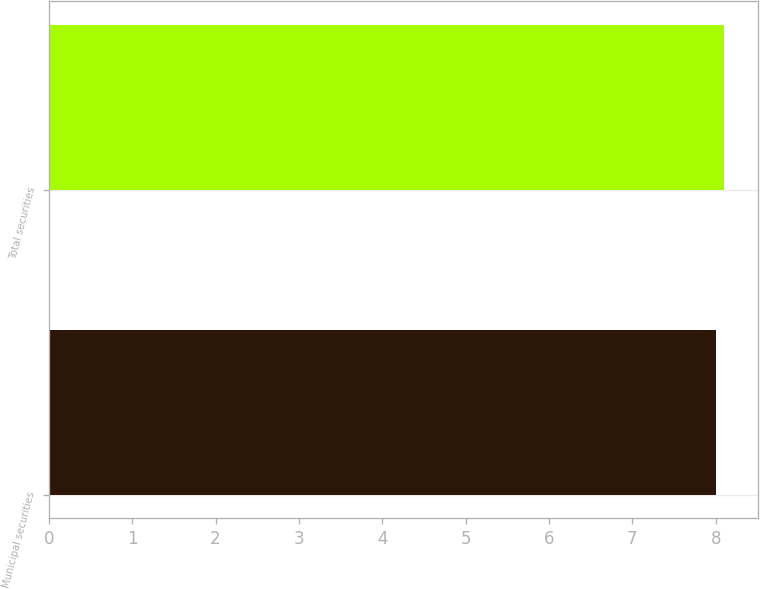Convert chart. <chart><loc_0><loc_0><loc_500><loc_500><bar_chart><fcel>Municipal securities<fcel>Total securities<nl><fcel>8<fcel>8.1<nl></chart> 